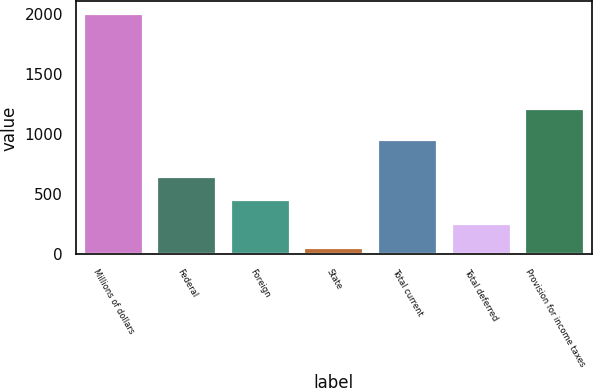<chart> <loc_0><loc_0><loc_500><loc_500><bar_chart><fcel>Millions of dollars<fcel>Federal<fcel>Foreign<fcel>State<fcel>Total current<fcel>Total deferred<fcel>Provision for income taxes<nl><fcel>2008<fcel>645.6<fcel>449.8<fcel>50<fcel>957<fcel>254<fcel>1211<nl></chart> 